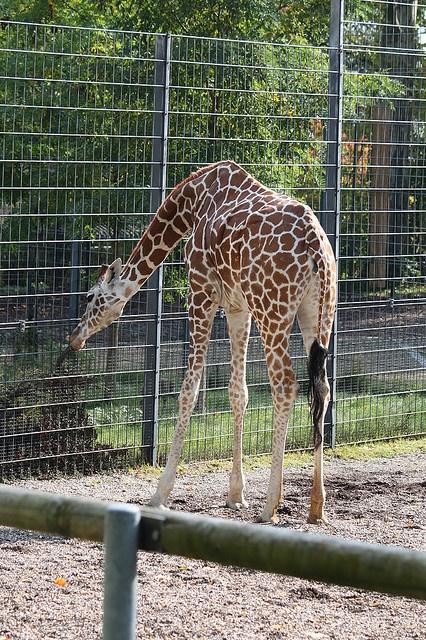Describe the objects in this image and their specific colors. I can see a giraffe in darkgreen, darkgray, maroon, gray, and black tones in this image. 